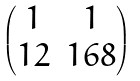<formula> <loc_0><loc_0><loc_500><loc_500>\begin{pmatrix} 1 & 1 \\ 1 2 & 1 6 8 \end{pmatrix}</formula> 